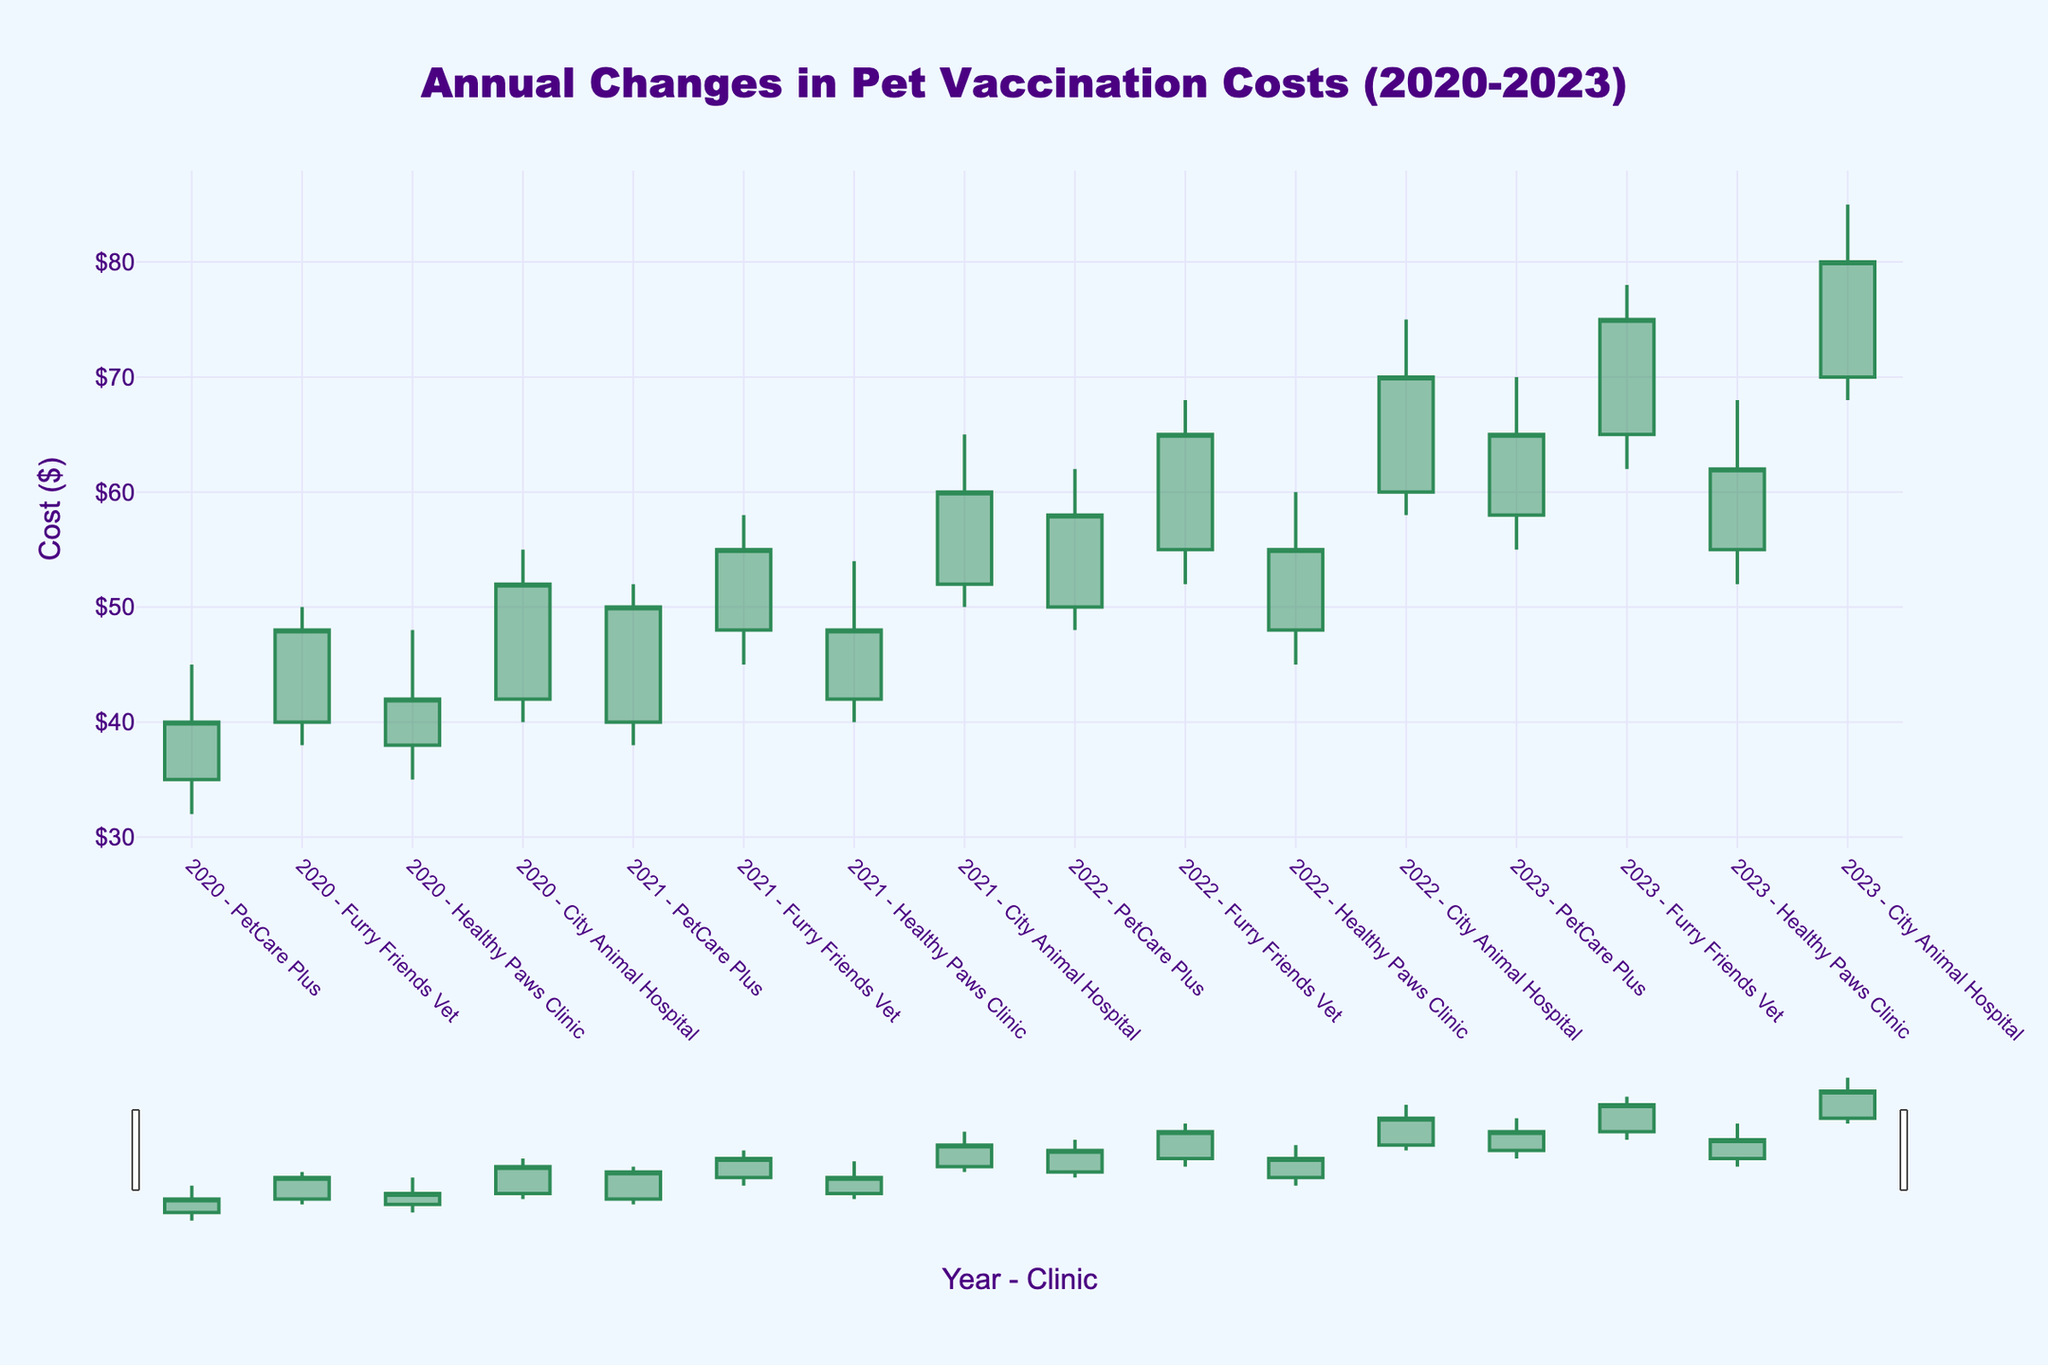What is the title of the figure? The title of the figure is usually located near the top center and is styled with a larger font size and distinct color. It summarizes what the figure represents.
Answer: Annual Changes in Pet Vaccination Costs (2020-2023) How many veterinary clinics are represented in the figure? You can identify the number of clinics by looking at the unique names in the x-axis label, which combines year and clinic name.
Answer: Four What is the cost range for PetCare Plus in 2023? For the OHLC chart, the cost range is between the low value and the high value for the given year and clinic. For 2023, these values are represented as 55 (low) and 70 (high).
Answer: $55-$70 Which clinic had the highest vaccination cost in 2021, and what was that cost? The highest value on the y-axis within 2021 needs to be checked for each clinic. Here, City Animal Hospital had the highest cost in 2021, reaching up to 65.
Answer: City Animal Hospital, $65 Did the vaccination cost for Furry Friends Vet increase or decrease from 2020 to 2023? Look at the close prices for 2020 and 2023 for Furry Friends Vet, which are 48 and 75 respectively. Since 75 is higher than 48, the cost increased.
Answer: Increase What was the lowest vaccination cost for City Animal Hospital over the entire period? The lowest points across the years for City Animal Hospital (2020-2023) need to be identified. The 2020 low was 40, 2021 low was 50, 2022 low was 58, and 2023 low was 68. The minimum among these values is 40.
Answer: $40 In which year did the vaccination cost for Healthy Paws Clinic close at the highest value? The close prices for Healthy Paws Clinic across the years should be examined: 42 in 2020, 48 in 2021, 55 in 2022, and 62 in 2023. The highest close price is 62 in 2023.
Answer: 2023 What is the average of the opening costs for PetCare Plus over the years 2020 to 2023? Add the opening costs for PetCare Plus for all four years (35 + 40 + 50 + 58) and divide by 4. This calculation gives an average of (35+40+50+58)/4 = 183/4 = 45.75.
Answer: $45.75 Compare the range of vaccination costs for Healthy Paws Clinic in 2022 with Furry Friends Vet in the same year. Which clinic had a larger range? Calculate the range by subtracting the low from the high value for both clinics: Healthy Paws Clinic (60 - 45 = 15) and Furry Friends Vet (68 - 52 = 16). Furry Friends Vet had a larger range.
Answer: Furry Friends Vet Which clinic appears to have the most volatile vaccination costs from 2020 to 2023? Volatility is observed by the largest range in values. Identify the clinic with the largest difference between highs and lows across all years: City Animal Hospital seems most volatile with highs up to 85 and lows as low as 40.
Answer: City Animal Hospital 